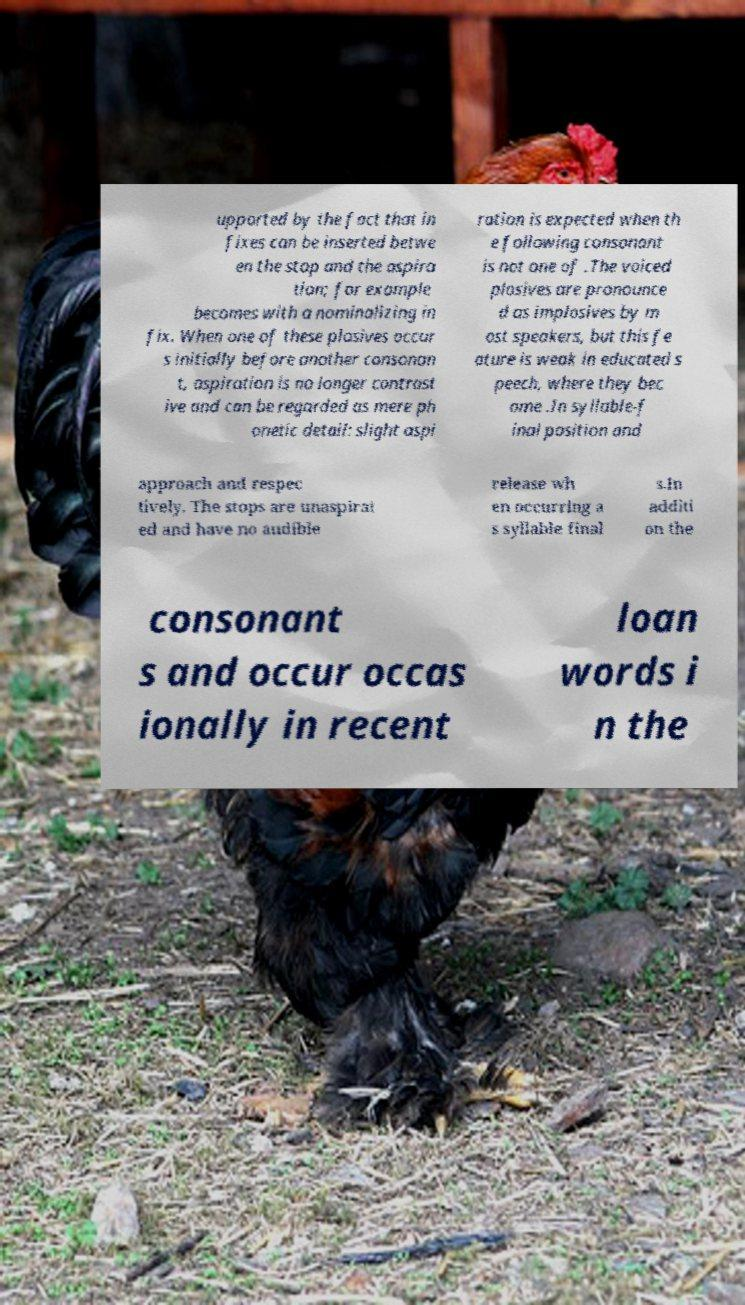Could you assist in decoding the text presented in this image and type it out clearly? upported by the fact that in fixes can be inserted betwe en the stop and the aspira tion; for example becomes with a nominalizing in fix. When one of these plosives occur s initially before another consonan t, aspiration is no longer contrast ive and can be regarded as mere ph onetic detail: slight aspi ration is expected when th e following consonant is not one of .The voiced plosives are pronounce d as implosives by m ost speakers, but this fe ature is weak in educated s peech, where they bec ome .In syllable-f inal position and approach and respec tively. The stops are unaspirat ed and have no audible release wh en occurring a s syllable final s.In additi on the consonant s and occur occas ionally in recent loan words i n the 